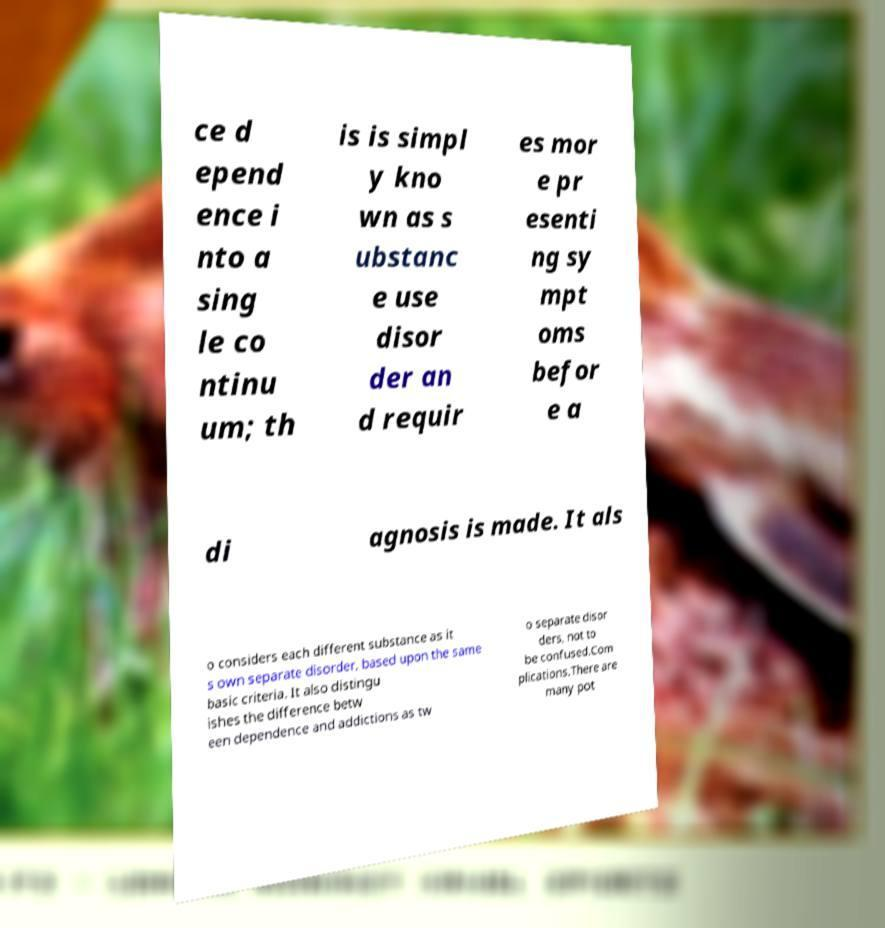Please identify and transcribe the text found in this image. ce d epend ence i nto a sing le co ntinu um; th is is simpl y kno wn as s ubstanc e use disor der an d requir es mor e pr esenti ng sy mpt oms befor e a di agnosis is made. It als o considers each different substance as it s own separate disorder, based upon the same basic criteria. It also distingu ishes the difference betw een dependence and addictions as tw o separate disor ders, not to be confused.Com plications.There are many pot 